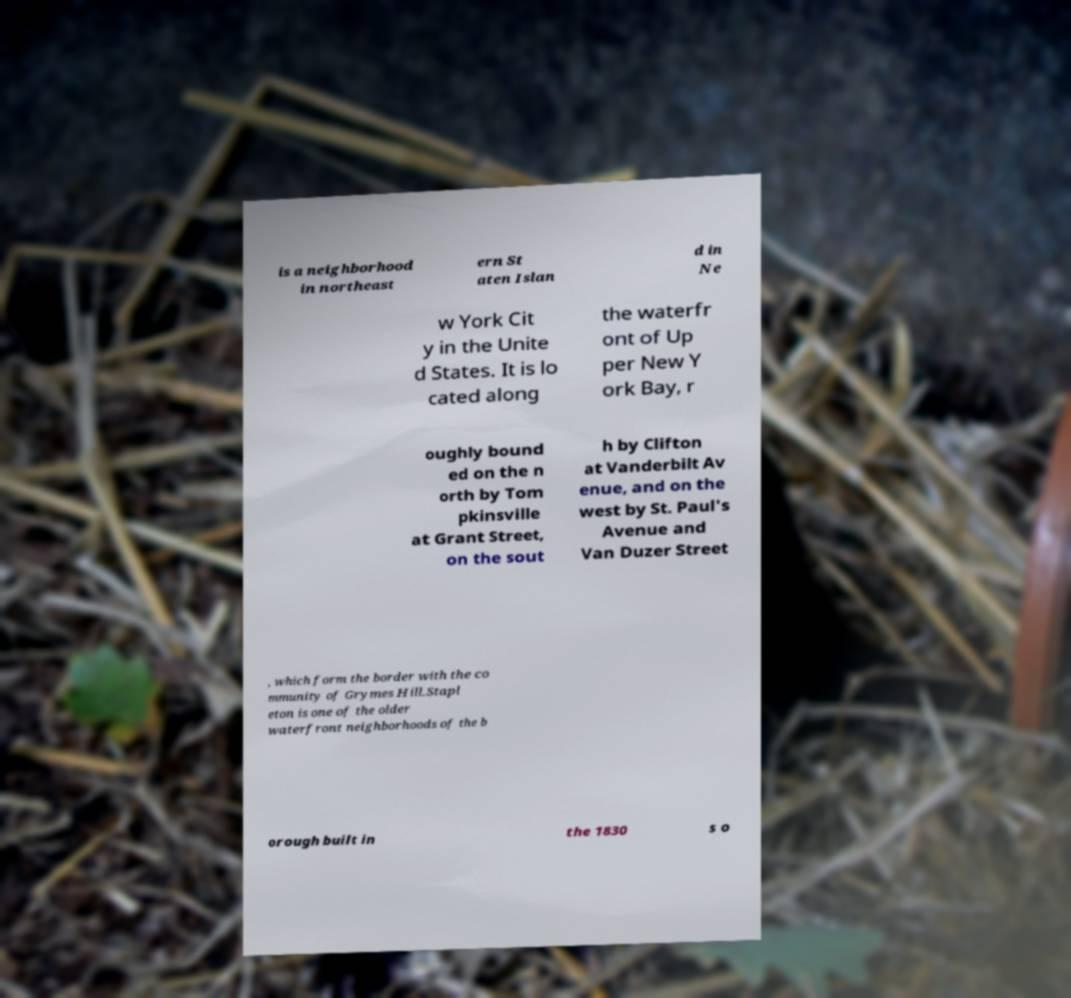Could you extract and type out the text from this image? is a neighborhood in northeast ern St aten Islan d in Ne w York Cit y in the Unite d States. It is lo cated along the waterfr ont of Up per New Y ork Bay, r oughly bound ed on the n orth by Tom pkinsville at Grant Street, on the sout h by Clifton at Vanderbilt Av enue, and on the west by St. Paul's Avenue and Van Duzer Street , which form the border with the co mmunity of Grymes Hill.Stapl eton is one of the older waterfront neighborhoods of the b orough built in the 1830 s o 